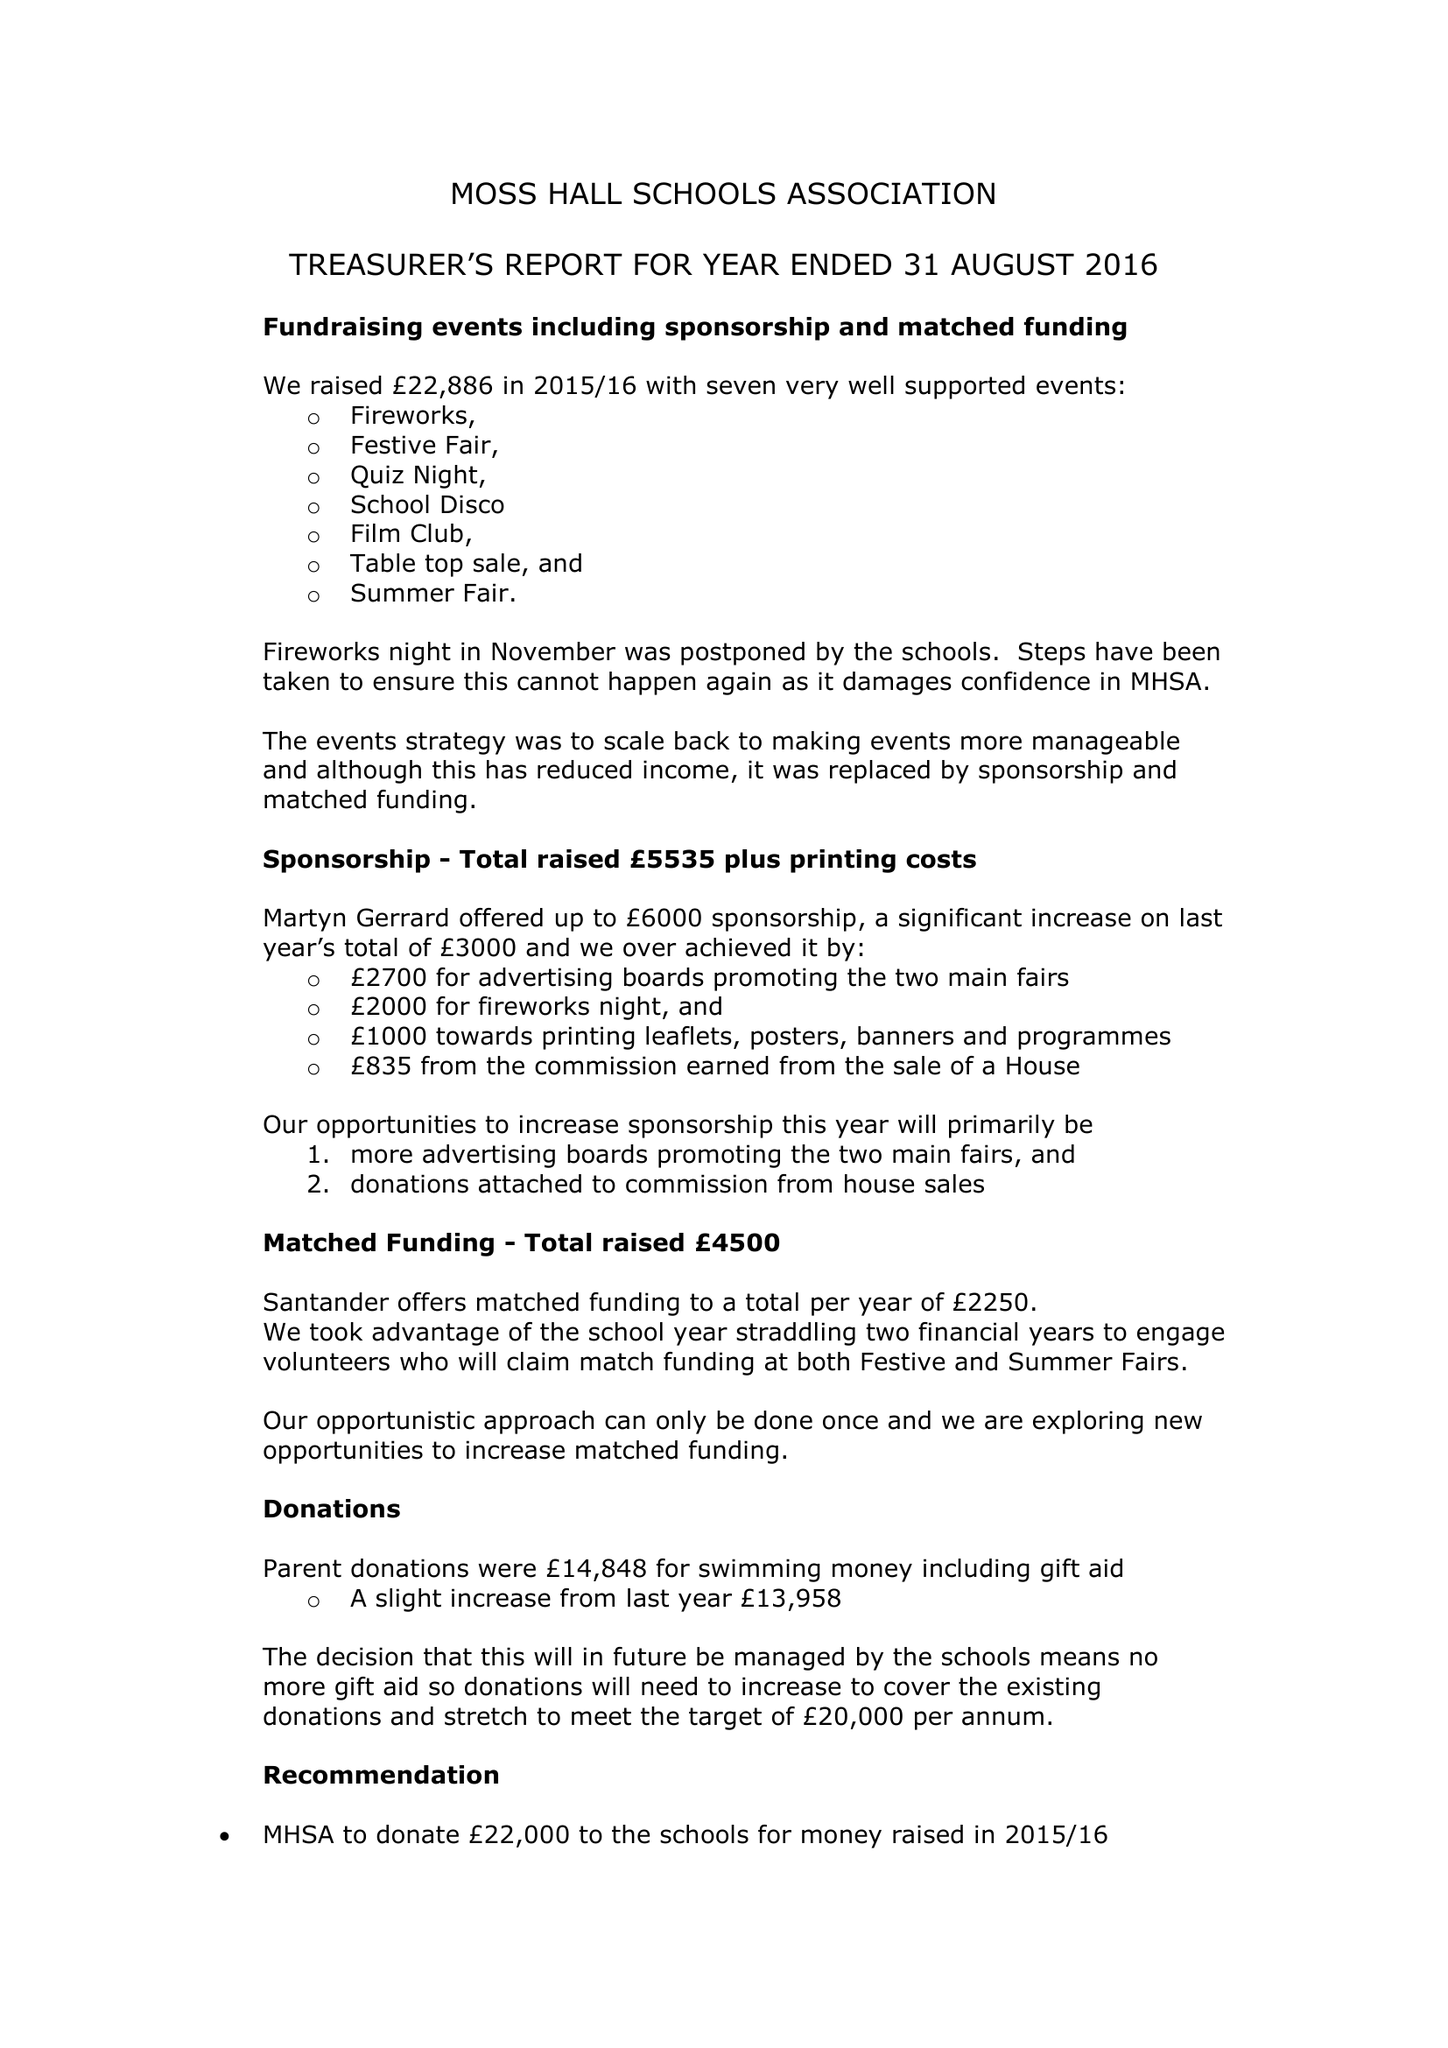What is the value for the address__postcode?
Answer the question using a single word or phrase. None 